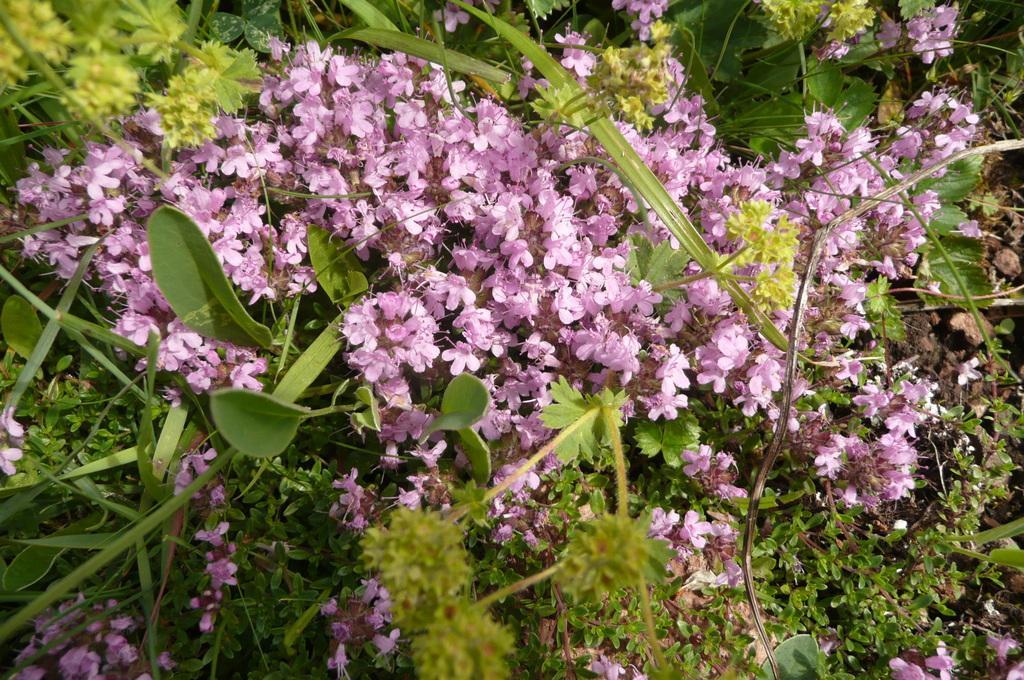Describe this image in one or two sentences. In this image I see the planets and I see flowers which are of pink in color. 